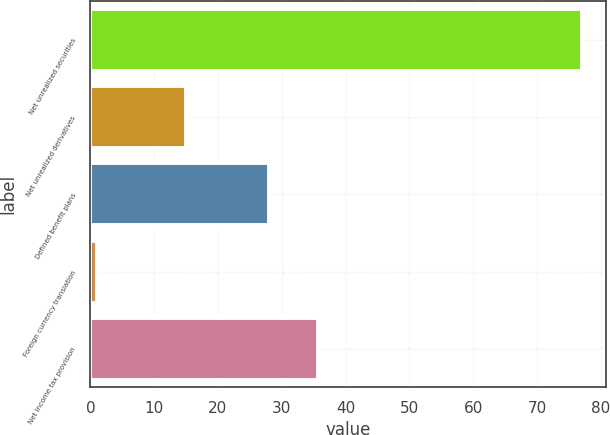Convert chart to OTSL. <chart><loc_0><loc_0><loc_500><loc_500><bar_chart><fcel>Net unrealized securities<fcel>Net unrealized derivatives<fcel>Defined benefit plans<fcel>Foreign currency translation<fcel>Net income tax provision<nl><fcel>77<fcel>15<fcel>28<fcel>1<fcel>35.6<nl></chart> 